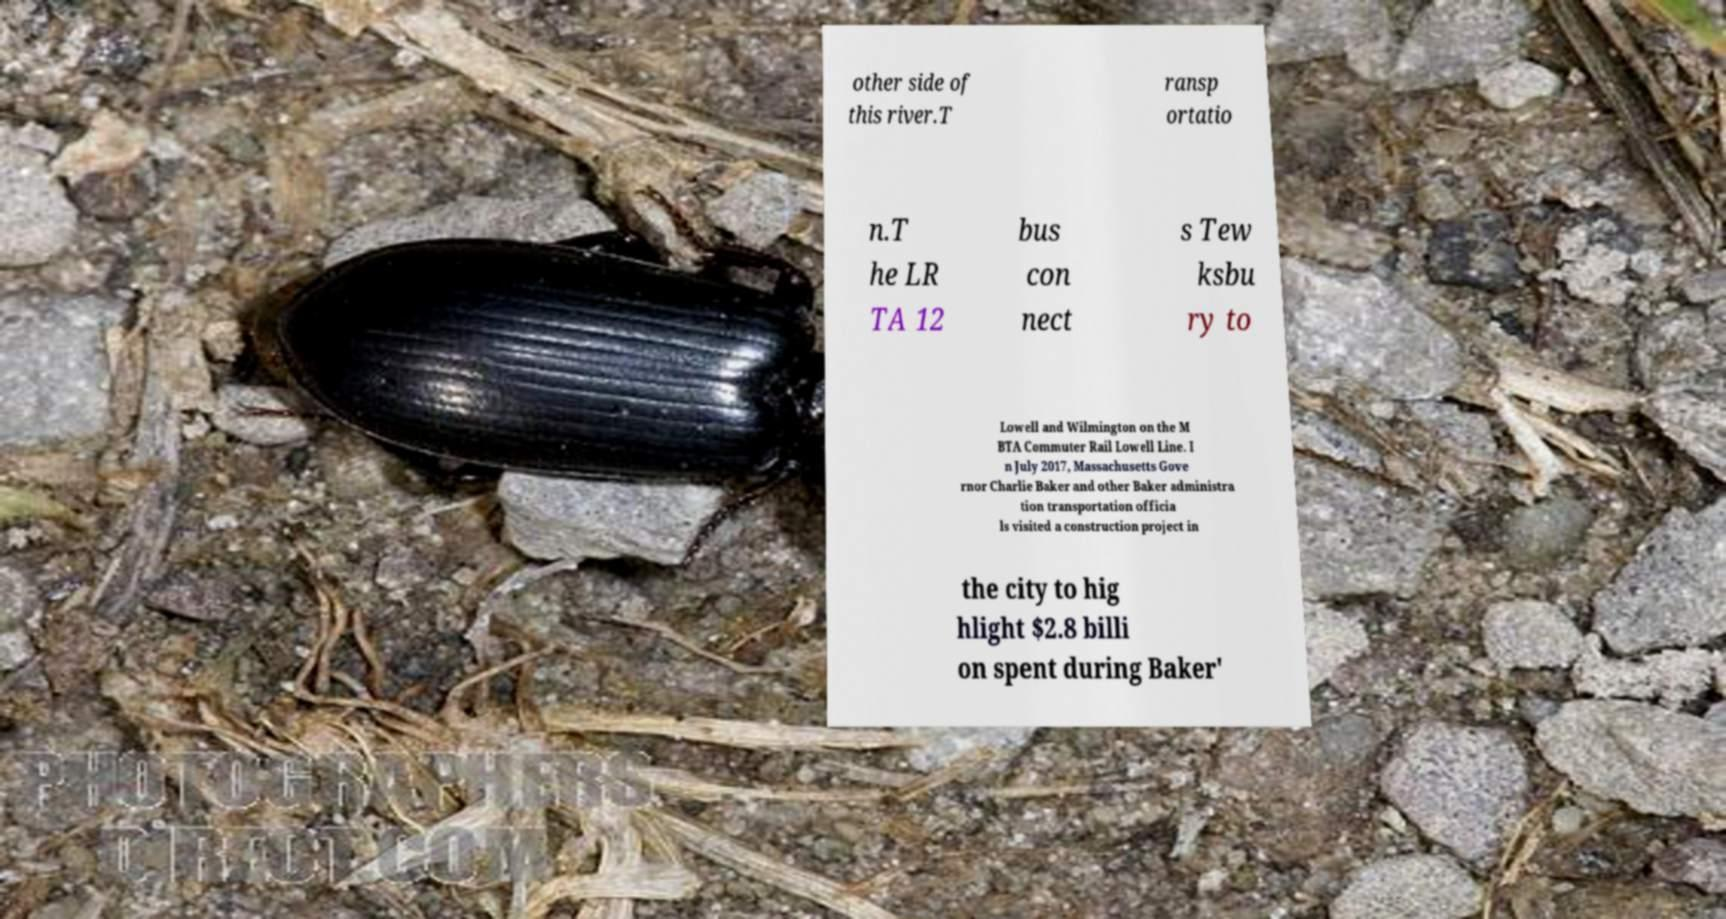Could you extract and type out the text from this image? other side of this river.T ransp ortatio n.T he LR TA 12 bus con nect s Tew ksbu ry to Lowell and Wilmington on the M BTA Commuter Rail Lowell Line. I n July 2017, Massachusetts Gove rnor Charlie Baker and other Baker administra tion transportation officia ls visited a construction project in the city to hig hlight $2.8 billi on spent during Baker' 